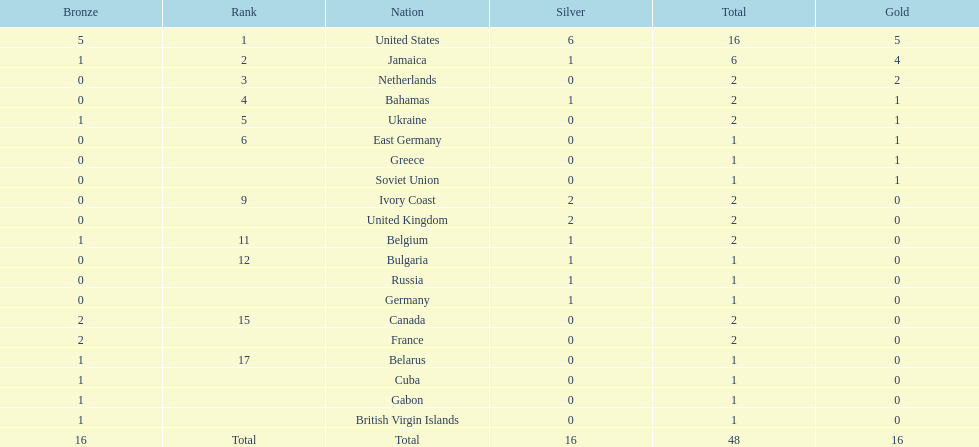What is the mean count of gold medals obtained by the leading five countries? 2.6. 